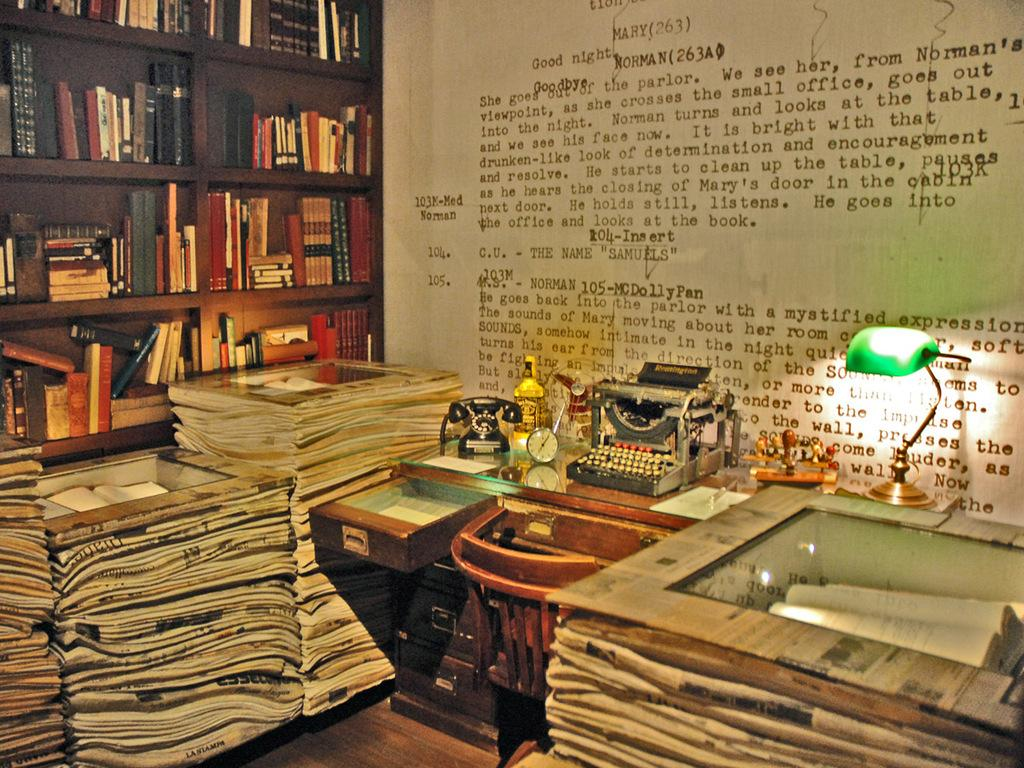<image>
Create a compact narrative representing the image presented. A wall features a blown-up display of a script, which has dialogue between the characters Mary and Norman. 